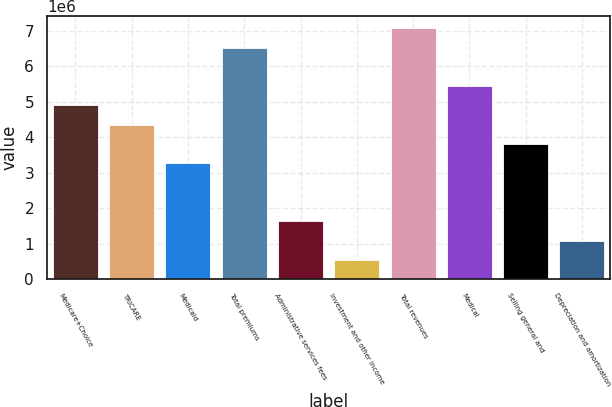Convert chart to OTSL. <chart><loc_0><loc_0><loc_500><loc_500><bar_chart><fcel>Medicare+Choice<fcel>TRICARE<fcel>Medicaid<fcel>Total premiums<fcel>Administrative services fees<fcel>Investment and other income<fcel>Total revenues<fcel>Medical<fcel>Selling general and<fcel>Depreciation and amortization<nl><fcel>4.89267e+06<fcel>4.34939e+06<fcel>3.26285e+06<fcel>6.52249e+06<fcel>1.63303e+06<fcel>546484<fcel>7.06576e+06<fcel>5.43594e+06<fcel>3.80612e+06<fcel>1.08976e+06<nl></chart> 